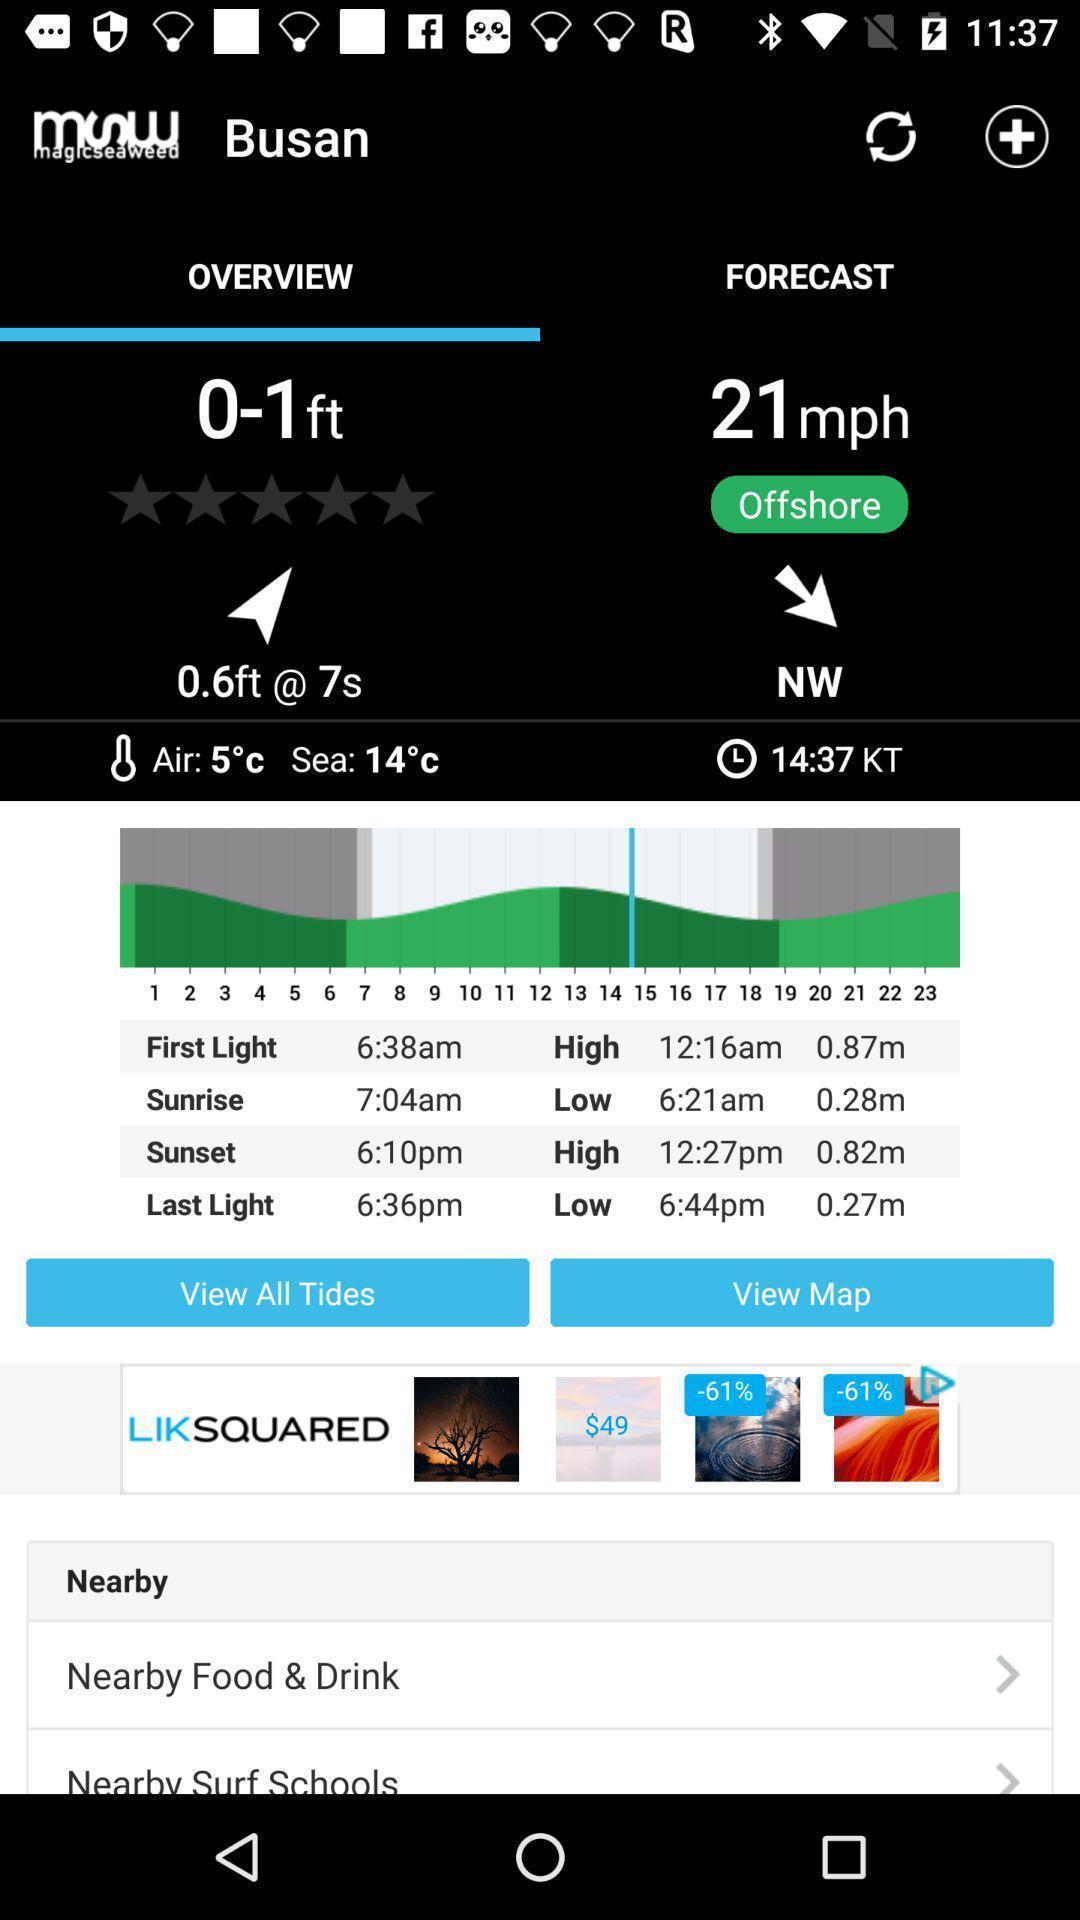Tell me what you see in this picture. Page shows overview. 